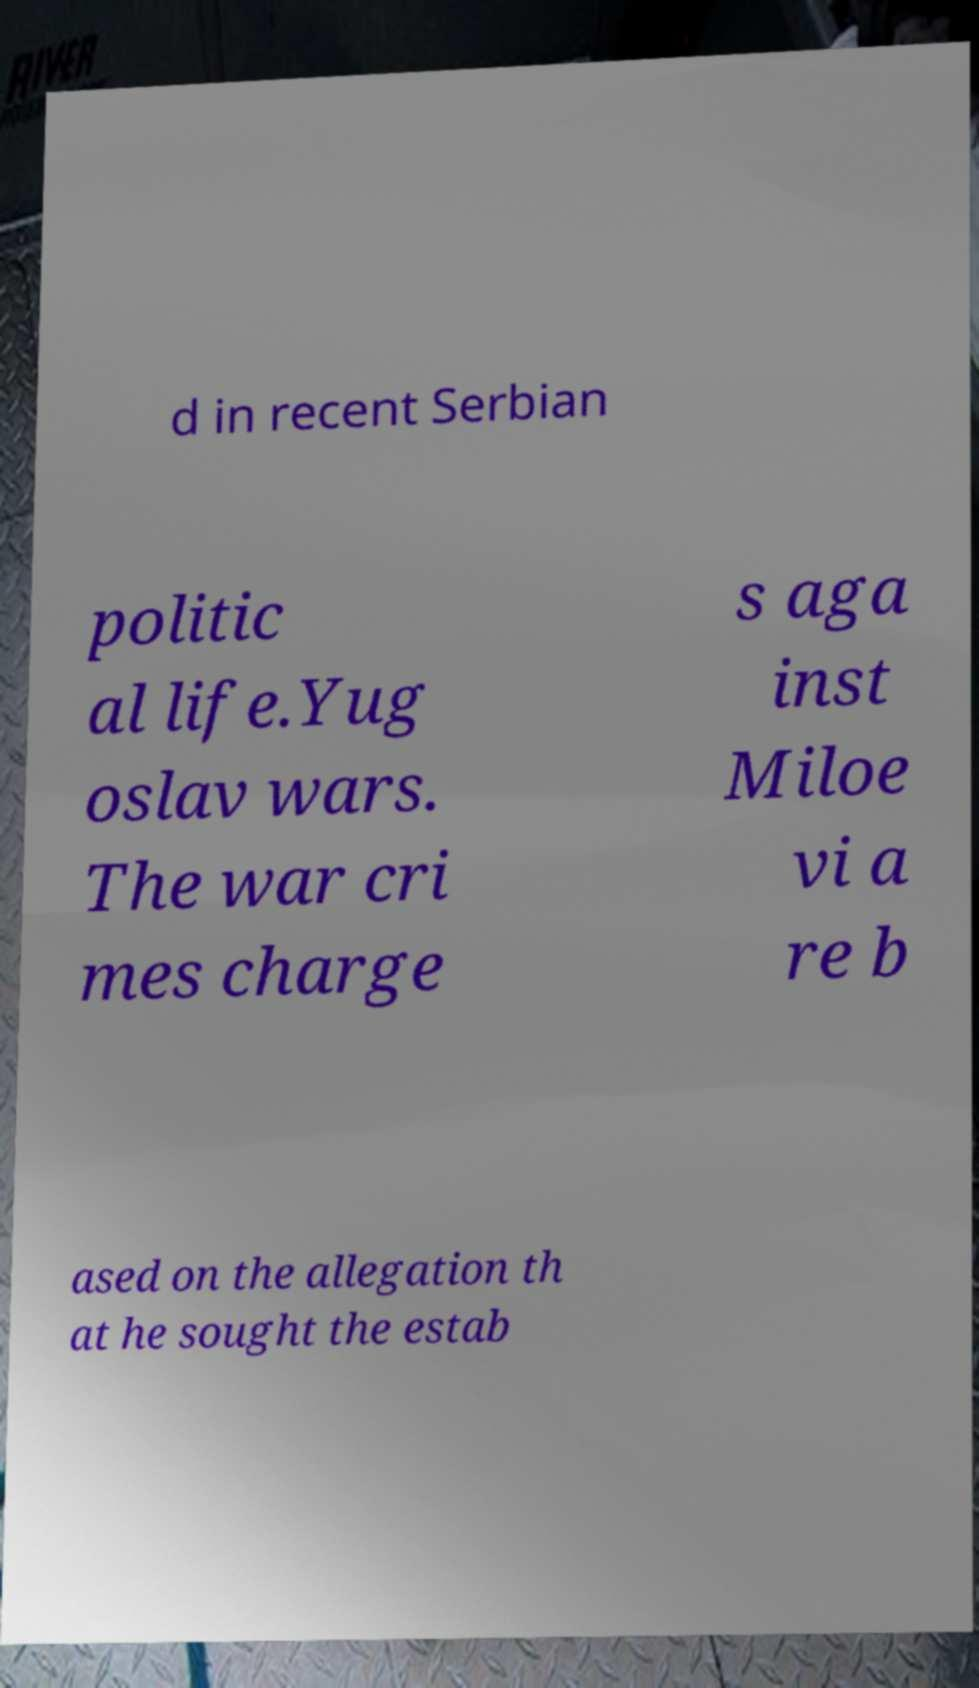For documentation purposes, I need the text within this image transcribed. Could you provide that? d in recent Serbian politic al life.Yug oslav wars. The war cri mes charge s aga inst Miloe vi a re b ased on the allegation th at he sought the estab 